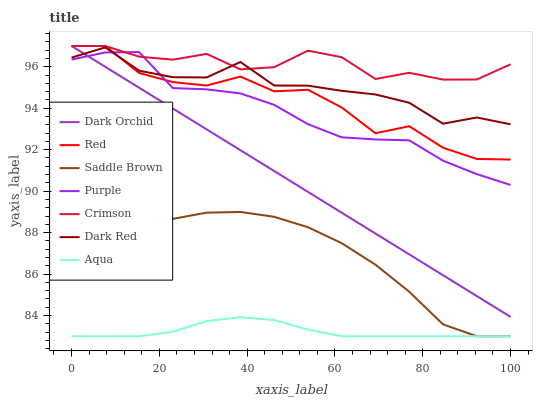Does Aqua have the minimum area under the curve?
Answer yes or no. Yes. Does Crimson have the maximum area under the curve?
Answer yes or no. Yes. Does Dark Red have the minimum area under the curve?
Answer yes or no. No. Does Dark Red have the maximum area under the curve?
Answer yes or no. No. Is Dark Orchid the smoothest?
Answer yes or no. Yes. Is Red the roughest?
Answer yes or no. Yes. Is Dark Red the smoothest?
Answer yes or no. No. Is Dark Red the roughest?
Answer yes or no. No. Does Aqua have the lowest value?
Answer yes or no. Yes. Does Dark Red have the lowest value?
Answer yes or no. No. Does Red have the highest value?
Answer yes or no. Yes. Does Dark Red have the highest value?
Answer yes or no. No. Is Aqua less than Red?
Answer yes or no. Yes. Is Dark Red greater than Aqua?
Answer yes or no. Yes. Does Purple intersect Dark Red?
Answer yes or no. Yes. Is Purple less than Dark Red?
Answer yes or no. No. Is Purple greater than Dark Red?
Answer yes or no. No. Does Aqua intersect Red?
Answer yes or no. No. 